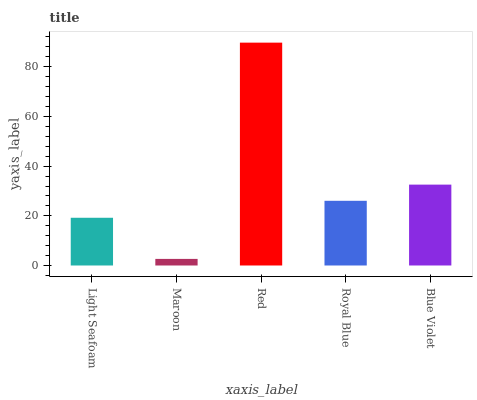Is Maroon the minimum?
Answer yes or no. Yes. Is Red the maximum?
Answer yes or no. Yes. Is Red the minimum?
Answer yes or no. No. Is Maroon the maximum?
Answer yes or no. No. Is Red greater than Maroon?
Answer yes or no. Yes. Is Maroon less than Red?
Answer yes or no. Yes. Is Maroon greater than Red?
Answer yes or no. No. Is Red less than Maroon?
Answer yes or no. No. Is Royal Blue the high median?
Answer yes or no. Yes. Is Royal Blue the low median?
Answer yes or no. Yes. Is Light Seafoam the high median?
Answer yes or no. No. Is Red the low median?
Answer yes or no. No. 